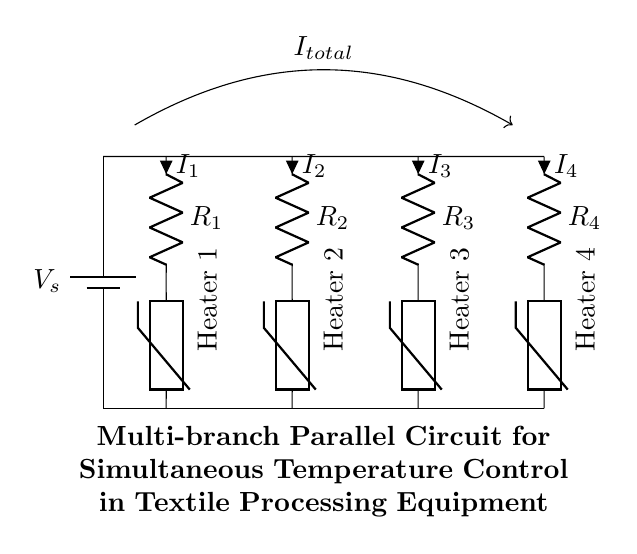What is the type of the circuit? The circuit is a parallel circuit because the branches are connected across the same two nodes, allowing each branch to operate independently while sharing the same voltage supply.
Answer: Parallel circuit How many branches are in the circuit? There are four branches in the circuit, each containing a resistor and a thermistor (heater), connected parallel to each other.
Answer: Four What component is used for temperature control in each branch? Each branch contains a thermistor, which is a temperature-sensitive resistor that changes its resistance based on temperature, used here for temperature control in the heaters.
Answer: Thermistor What is the total current flowing from the power supply? The total current is represented as I total in the diagram, which is the sum of the currents I1, I2, I3, and I4 flowing through each of the four branches providing an overall current from the battery to the circuit.
Answer: I total Which branch is associated with the heater labeled "Heater 3"? Heater 3 is associated with the third branch of the circuit, which connects to the resistor R3 and the thermistor for heat control in that particular path.
Answer: Third branch If one branch fails, how would that affect the other branches in the circuit? If one branch fails, it would not affect the operation of the other branches since they are connected in parallel, allowing the remaining branches to continue functioning independently.
Answer: No effect 